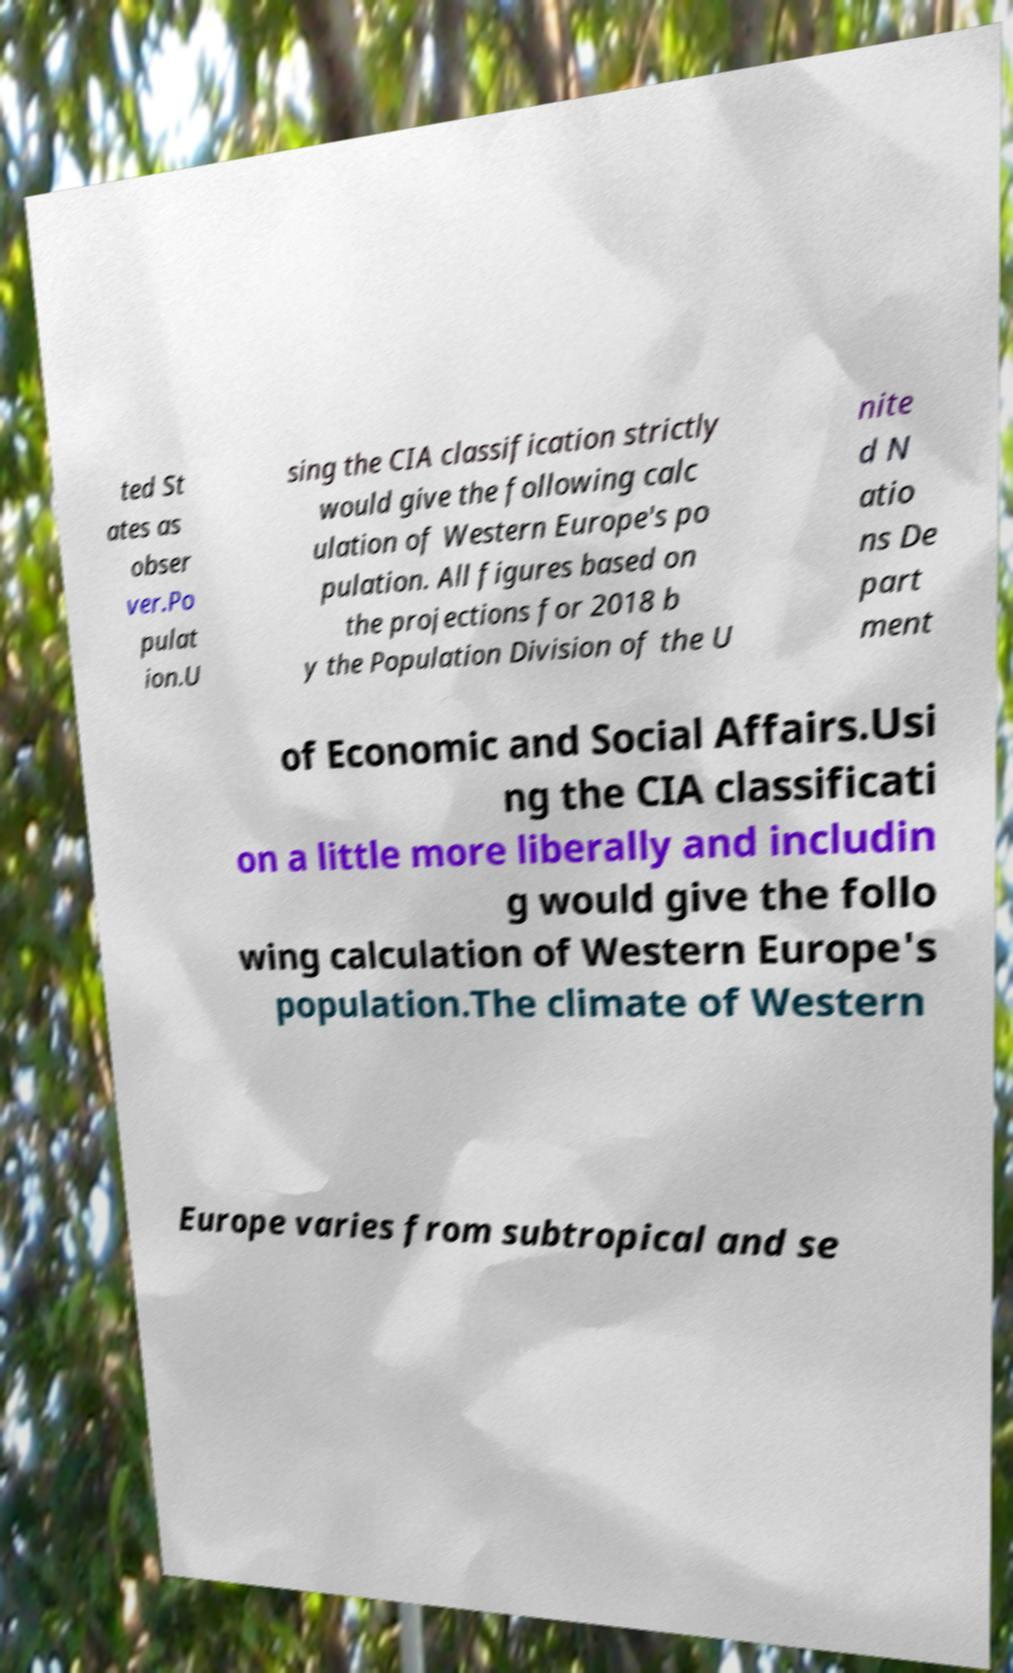Could you assist in decoding the text presented in this image and type it out clearly? ted St ates as obser ver.Po pulat ion.U sing the CIA classification strictly would give the following calc ulation of Western Europe's po pulation. All figures based on the projections for 2018 b y the Population Division of the U nite d N atio ns De part ment of Economic and Social Affairs.Usi ng the CIA classificati on a little more liberally and includin g would give the follo wing calculation of Western Europe's population.The climate of Western Europe varies from subtropical and se 